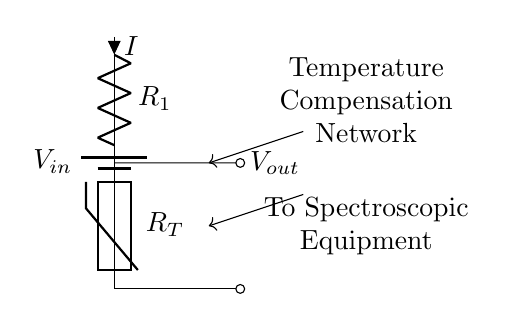What is the value of the input voltage? The circuit diagram indicates an input source represented by a battery symbol labeled V_in, but does not provide a numerical value for it. Therefore, we cannot specify a value.
Answer: Not specified What is the purpose of R1 in the circuit? R1 acts as a resistive element in the voltage divider network, determining the division of voltage with the thermistor. Its resistance directly impacts the output voltage and thus plays a crucial role in temperature compensation.
Answer: Voltage division What type of component is R_T? R_T represents a thermistor, which is a type of resistor whose resistance varies significantly with temperature. The diagram illustrates that R_T is connected in series with R1, enabling temperature-dependent voltage changes at V_out.
Answer: Thermistor What is the relationship between V_out and temperature? As temperature changes, the resistance of the thermistor R_T changes, which affects the output voltage V_out. The configuration of the voltage divider means that as R_T increases or decreases with temperature, it directly alters V_out, enabling temperature compensation in the spectroscopic equipment.
Answer: Directly related How does increasing R_T affect V_out? Increasing the resistance of R_T (thermistor) will result in a higher output voltage V_out due to the nature of the voltage divider rule, which states that output voltage is a function of the resistances in the circuit. This relationship implies that larger R_T relative to R1 leads to a proportionately larger V_out.
Answer: Increases V_out What happens if R1 is removed from the circuit? If R1 is removed, the circuit no longer functions as a voltage divider. The output voltage V_out would essentially equal the input voltage V_in because there would be a direct short to the thermistor, resulting in no voltage division. This would undermine its purpose in temperature compensation.
Answer: No voltage division 